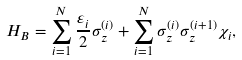Convert formula to latex. <formula><loc_0><loc_0><loc_500><loc_500>H _ { B } = \sum _ { i = 1 } ^ { N } \frac { \varepsilon _ { i } } { 2 } \sigma _ { z } ^ { ( i ) } + \sum _ { { i } = 1 } ^ { N } \sigma _ { z } ^ { ( i ) } \sigma _ { z } ^ { ( i + 1 ) } \chi _ { i } ,</formula> 